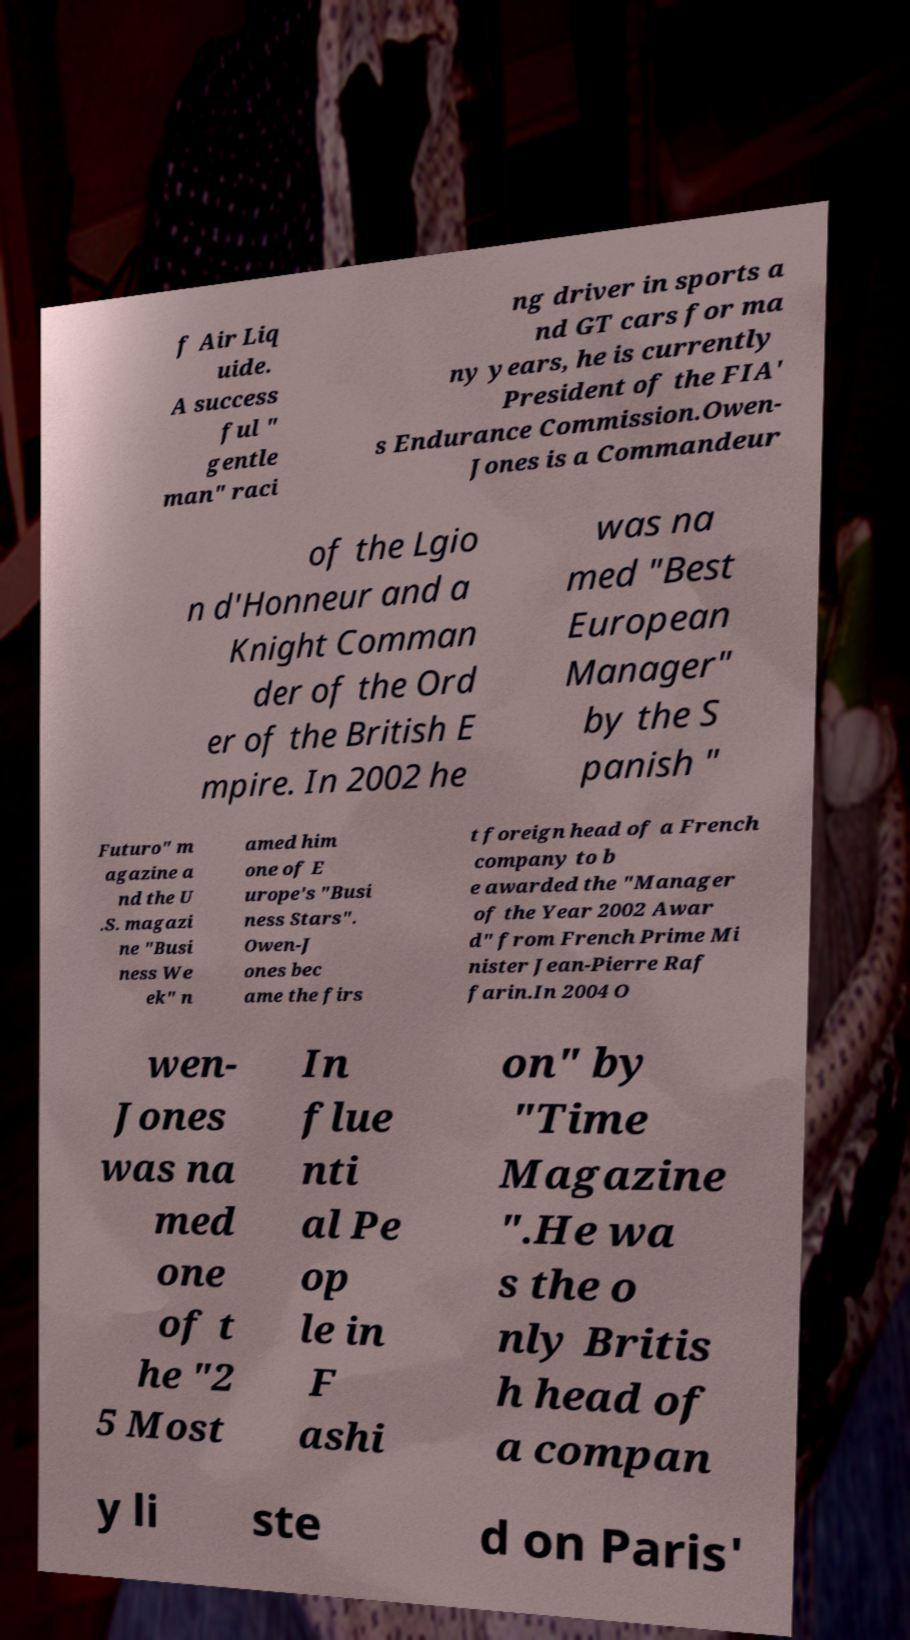What messages or text are displayed in this image? I need them in a readable, typed format. f Air Liq uide. A success ful " gentle man" raci ng driver in sports a nd GT cars for ma ny years, he is currently President of the FIA' s Endurance Commission.Owen- Jones is a Commandeur of the Lgio n d'Honneur and a Knight Comman der of the Ord er of the British E mpire. In 2002 he was na med "Best European Manager" by the S panish " Futuro" m agazine a nd the U .S. magazi ne "Busi ness We ek" n amed him one of E urope's "Busi ness Stars". Owen-J ones bec ame the firs t foreign head of a French company to b e awarded the "Manager of the Year 2002 Awar d" from French Prime Mi nister Jean-Pierre Raf farin.In 2004 O wen- Jones was na med one of t he "2 5 Most In flue nti al Pe op le in F ashi on" by "Time Magazine ".He wa s the o nly Britis h head of a compan y li ste d on Paris' 